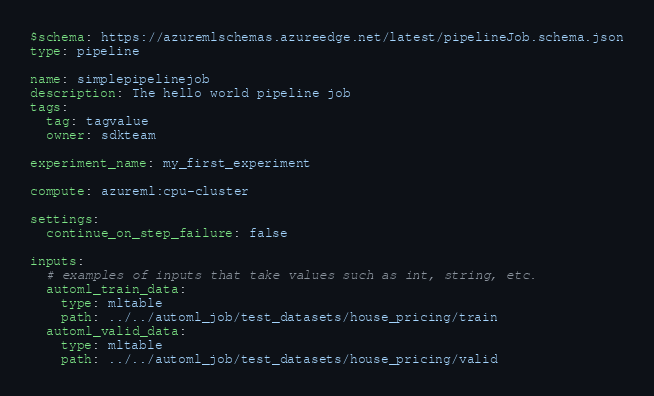Convert code to text. <code><loc_0><loc_0><loc_500><loc_500><_YAML_>$schema: https://azuremlschemas.azureedge.net/latest/pipelineJob.schema.json
type: pipeline

name: simplepipelinejob
description: The hello world pipeline job
tags:
  tag: tagvalue
  owner: sdkteam

experiment_name: my_first_experiment

compute: azureml:cpu-cluster

settings:
  continue_on_step_failure: false

inputs:
  # examples of inputs that take values such as int, string, etc.
  automl_train_data:
    type: mltable
    path: ../../automl_job/test_datasets/house_pricing/train
  automl_valid_data:
    type: mltable
    path: ../../automl_job/test_datasets/house_pricing/valid</code> 